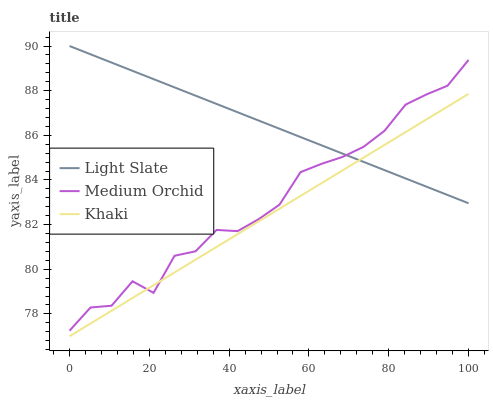Does Medium Orchid have the minimum area under the curve?
Answer yes or no. No. Does Medium Orchid have the maximum area under the curve?
Answer yes or no. No. Is Khaki the smoothest?
Answer yes or no. No. Is Khaki the roughest?
Answer yes or no. No. Does Medium Orchid have the lowest value?
Answer yes or no. No. Does Medium Orchid have the highest value?
Answer yes or no. No. 